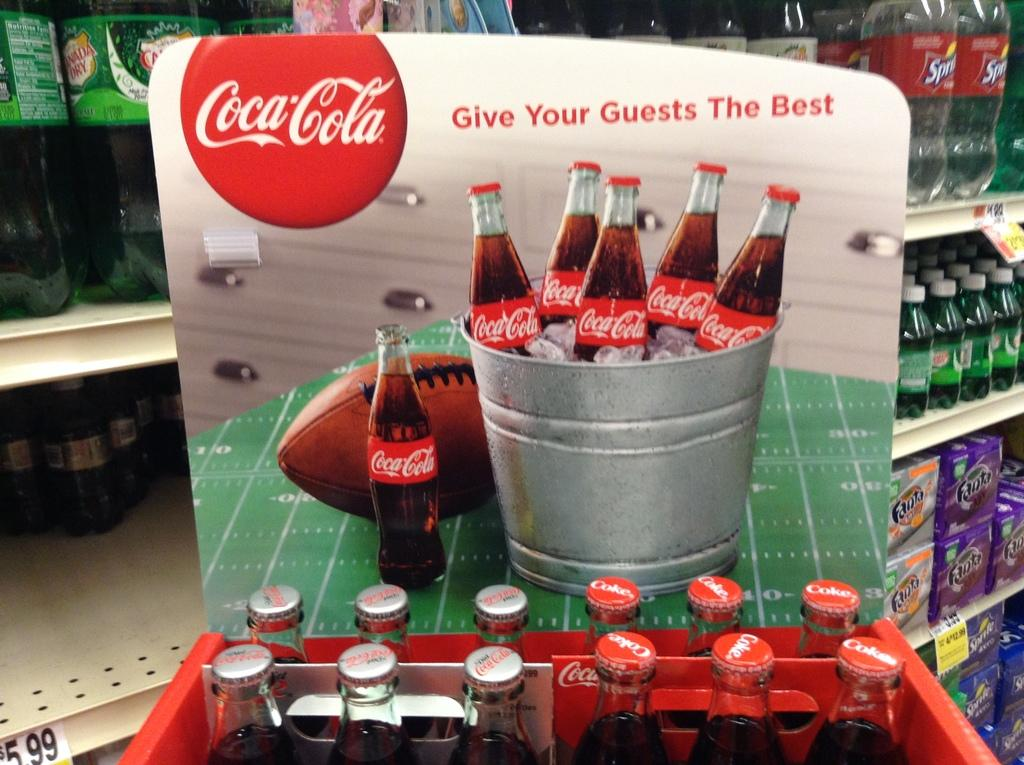What type of containers are visible in the image? There are glass bottles in the image. How are the glass bottles arranged or organized? The glass bottles are in a tray. What type of sack is being used to store the silver in the image? There is no sack or silver present in the image; it only features glass bottles in a tray. 